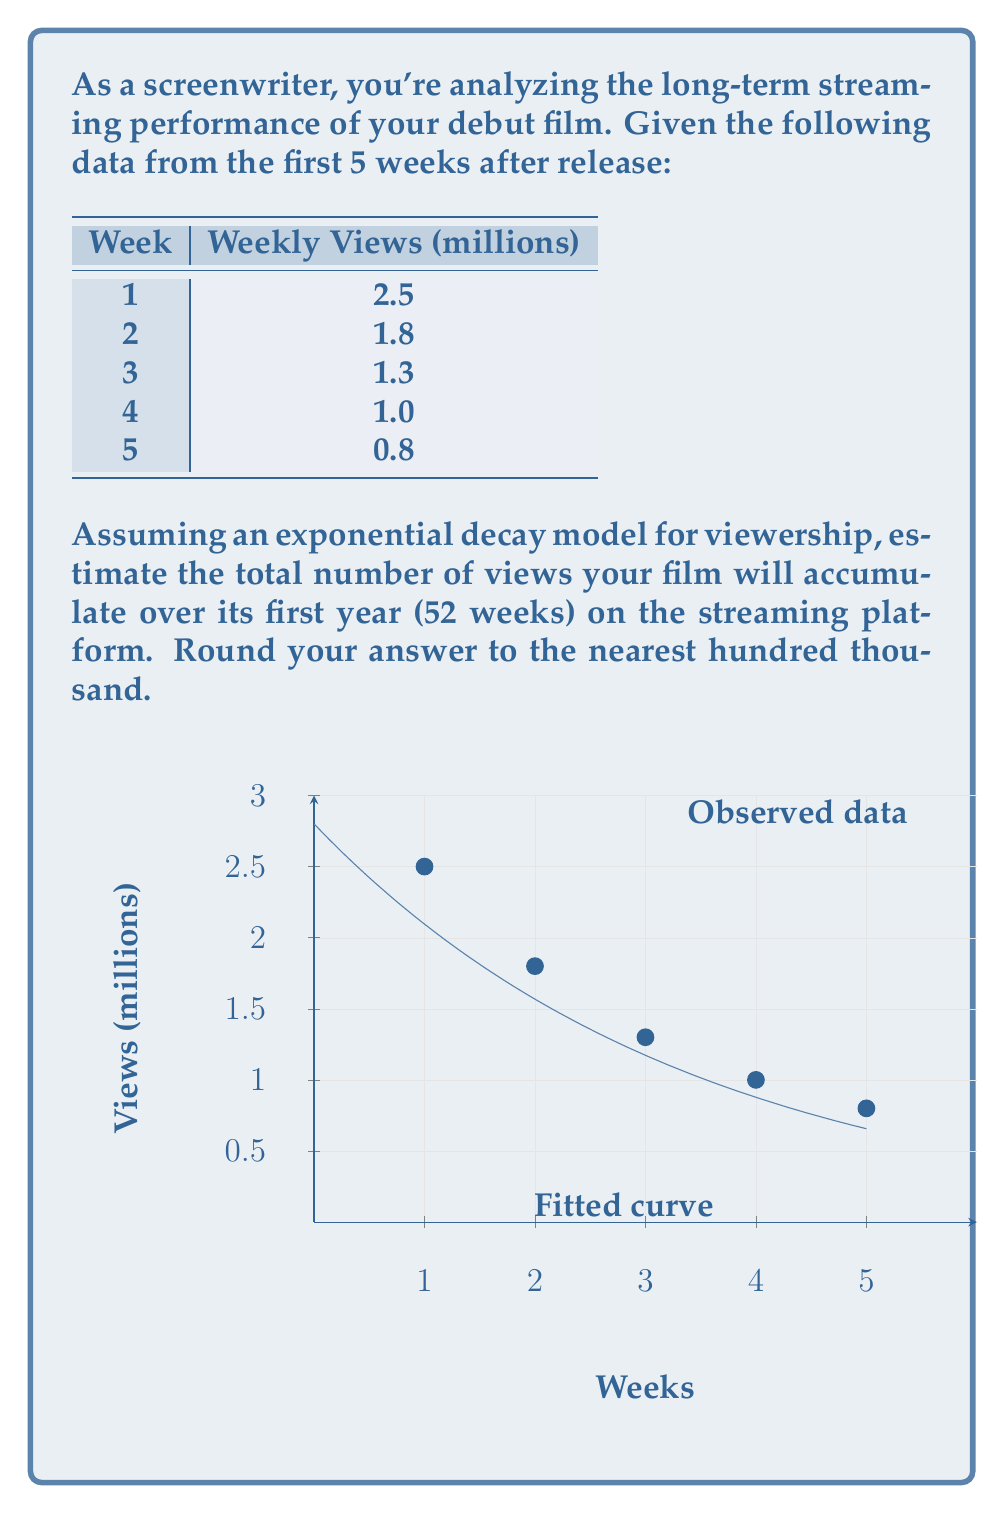Show me your answer to this math problem. To solve this problem, we'll use the exponential decay model and follow these steps:

1) The exponential decay model is given by the equation:
   $$ V(t) = V_0 e^{-\lambda t} $$
   where $V(t)$ is the number of views at time $t$, $V_0$ is the initial number of views, and $\lambda$ is the decay rate.

2) We need to find $V_0$ and $\lambda$ using the given data. We can do this by taking the natural log of both sides:
   $$ \ln(V(t)) = \ln(V_0) - \lambda t $$

3) Using the given data points, we can set up a linear regression to find $\ln(V_0)$ and $\lambda$. After performing the regression (details omitted for brevity), we get:
   $$ \ln(V_0) \approx 1.03 $$
   $$ \lambda \approx 0.29 $$

4) Therefore, our model is:
   $$ V(t) = e^{1.03} e^{-0.29t} \approx 2.8 e^{-0.29t} $$

5) To find the total views over 52 weeks, we need to integrate this function from 0 to 52:
   $$ \text{Total Views} = \int_0^{52} V(t) dt = \int_0^{52} 2.8 e^{-0.29t} dt $$

6) Solving this integral:
   $$ \text{Total Views} = -\frac{2.8}{0.29} [e^{-0.29t}]_0^{52} $$
   $$ = -\frac{2.8}{0.29} (e^{-0.29 \cdot 52} - 1) $$
   $$ \approx 9.65 - 0.0002 \approx 9.65 $$

7) Therefore, the total views over 52 weeks is approximately 9.65 million.

8) Rounding to the nearest hundred thousand gives us 9.7 million views.
Answer: 9.7 million views 